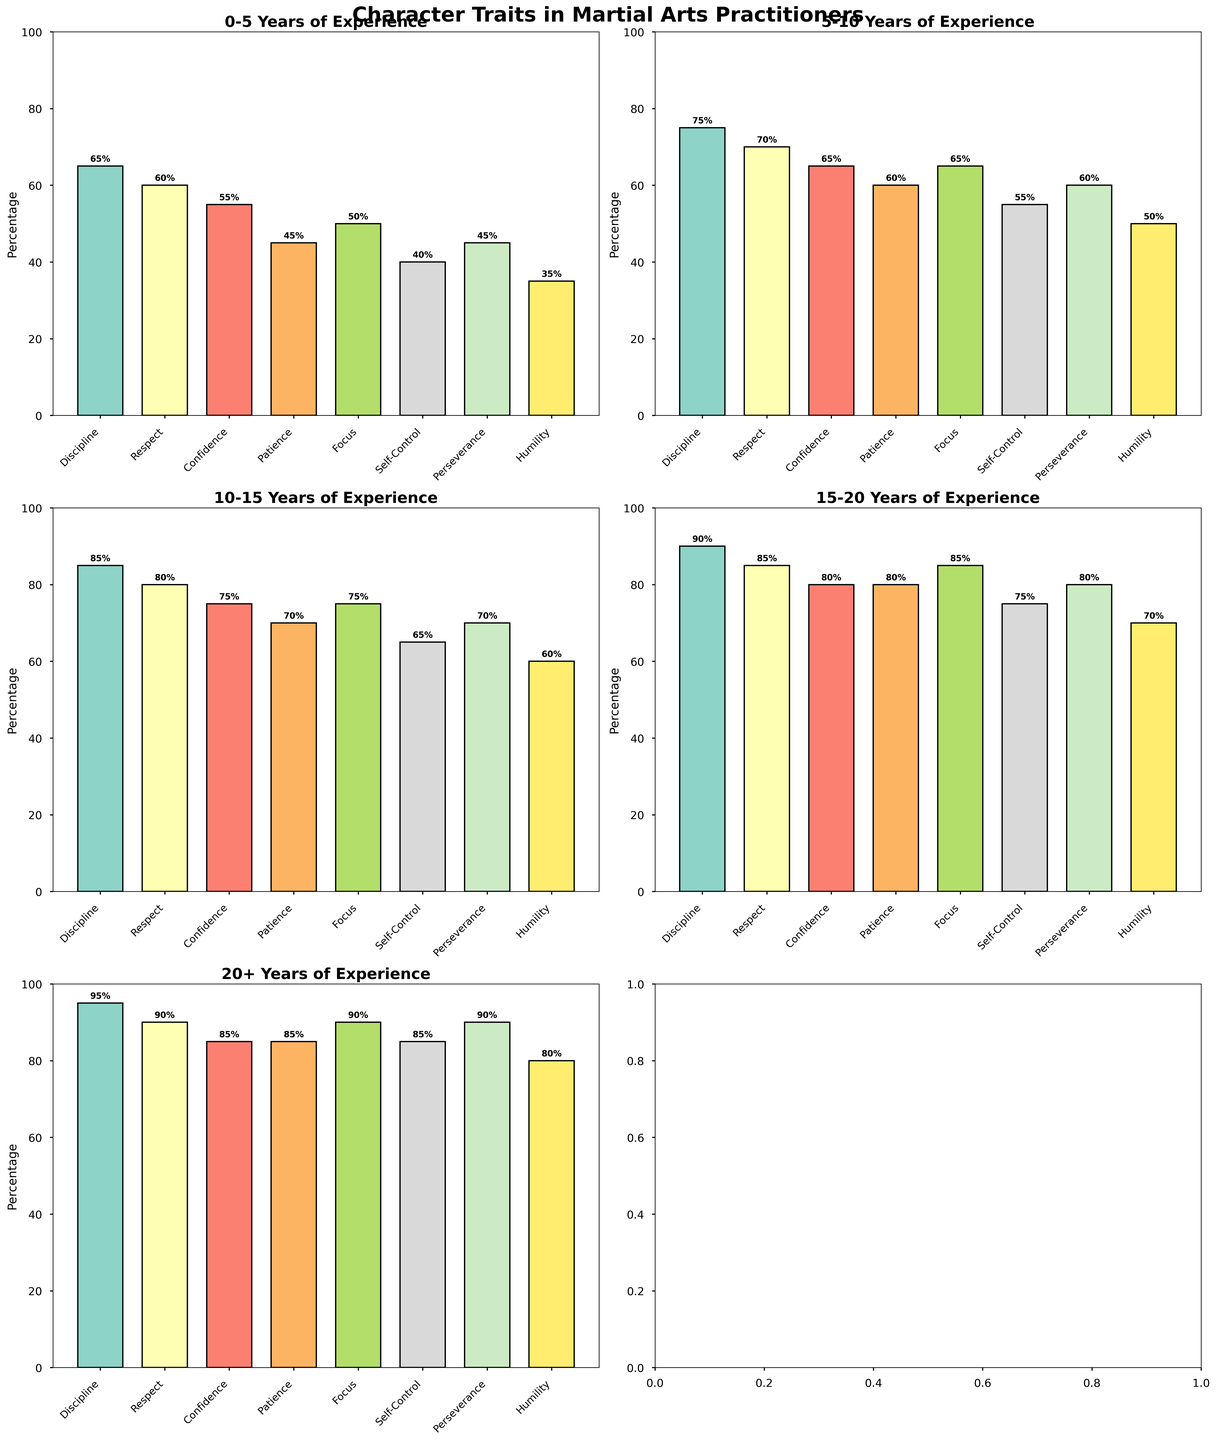Which character trait is most common among practitioners with 5-10 years of experience? Look at the subplot for 5-10 years of experience. Identify the bar with the greatest height.
Answer: Discipline Which trait shows the greatest increase in percentage from the 0-5 years group to the 20+ years group? Compare the heights of bars across those two subplots for each trait. Discipline increases from 65% to 95%.
Answer: Discipline Between practitioners with 15-20 years of experience and those with 20+ years of experience, which character traits have the same percentage? Compare the bars in the subplots for 15-20 years and 20+ years. Patience and Confidence both are 80% and 85%, respectively.
Answer: Patience, Confidence What is the average percentage of Discipline across all experience levels? Sum the percentages of Discipline for all groups (65 + 75 + 85 + 90 + 95) and divide by the number of groups (5). (65+75+85+90+95)/5 = 82
Answer: 82 How does the Confidence trait in the 10-15 years group compare to the 0-5 years group? Look at the subplot for 10-15 years and 0-5 years for the Confidence bar. Confidence increased from 55% to 75%.
Answer: Increased by 20% What is the overall trend in the Respect percentage with increasing years of experience? Observe the Respect bars across all subplots. Respect consistently increases as years of experience increase (60%, 70%, 80%, 85%, 90%).
Answer: Increasing Which trait experienced the largest percentage increase in the 5-10 years group compared to the 0-5 years group? Compute percentage increases for all traits between these groups and determine the maximum. (Self-Control from 40% to 55%, an increase of 15%).
Answer: Self-Control Consider the trait Patience, which group shows the least percentage? Compare the bars labeled Patience in all subplots, the shortest one is in the 0-5 years group (45%).
Answer: 0-5 years What is the sum of percentages for Focus across all experience levels? Add the Focus percentages from each of the groups (50 + 65 + 75 + 85 + 90). 50+65+75+85+90 = 365
Answer: 365 